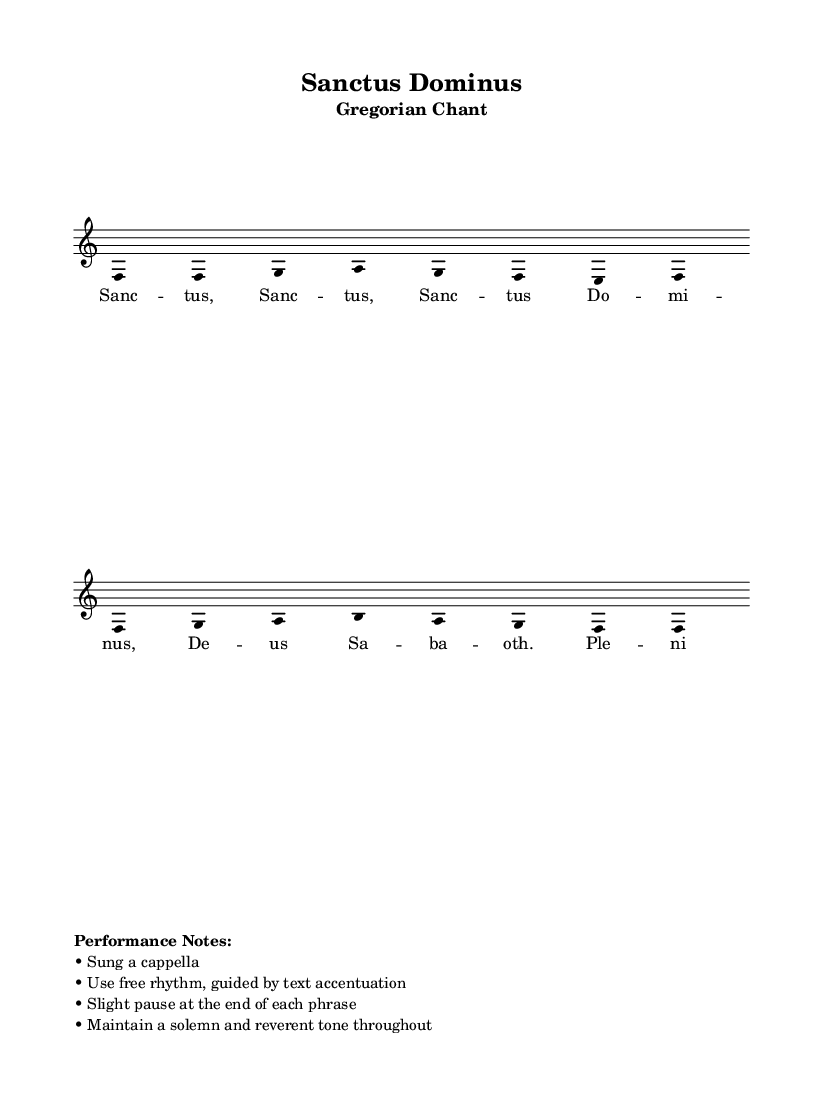What is the key signature of this music? The key signature is G major, which has one sharp (F#). This can be identified by looking at the key signature in the music sheet before the treble clef, which indicates the note that should be sharped.
Answer: G major What is the time signature of the piece? The time signature is 4/4, which indicates that there are four beats in each measure and that a quarter note receives one beat. This is shown directly in the music by the notation following the clef.
Answer: 4/4 How many notes are there in the first phrase? The first phrase consists of eight notes: g, g, a, b, a, g, f, g. This can be counted directly from the melody line, as it shows each individual note in the notation.
Answer: Eight What style of singing is suggested for this piece? The performance notes indicate that the piece should be sung a cappella, meaning without instrumental accompaniment. This is specifically mentioned in the performance notes section of the score.
Answer: A cappella Which text is set to the melody? The melody is set to the text "Sanctus, Sanctus, Sanctus Dominus, Deus Sabbaoth." This can be determined from the lyrics provided underneath the melody in the music sheet.
Answer: Sanctus, Sanctus, Sanctus Dominus, Deus Sabbaoth What does the term 'mixolydian' refer to in this context? The term 'mixolydian' refers to the specific mode used for the melody, characterized by a major scale with a lowered seventh. In the context of this score, it explains the characteristic sound of the music, as indicated in the global section.
Answer: A musical mode 